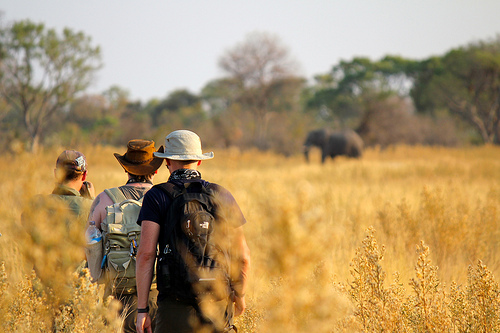Is there any backpack that is large? Yes, there is a large backpack. 